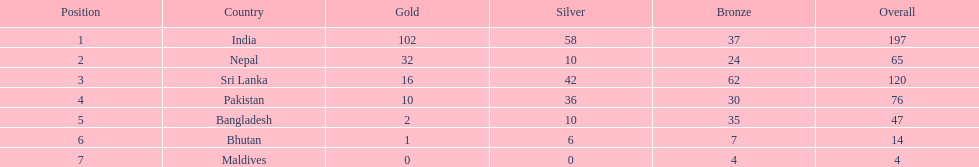How many gold medals did india win? 102. 